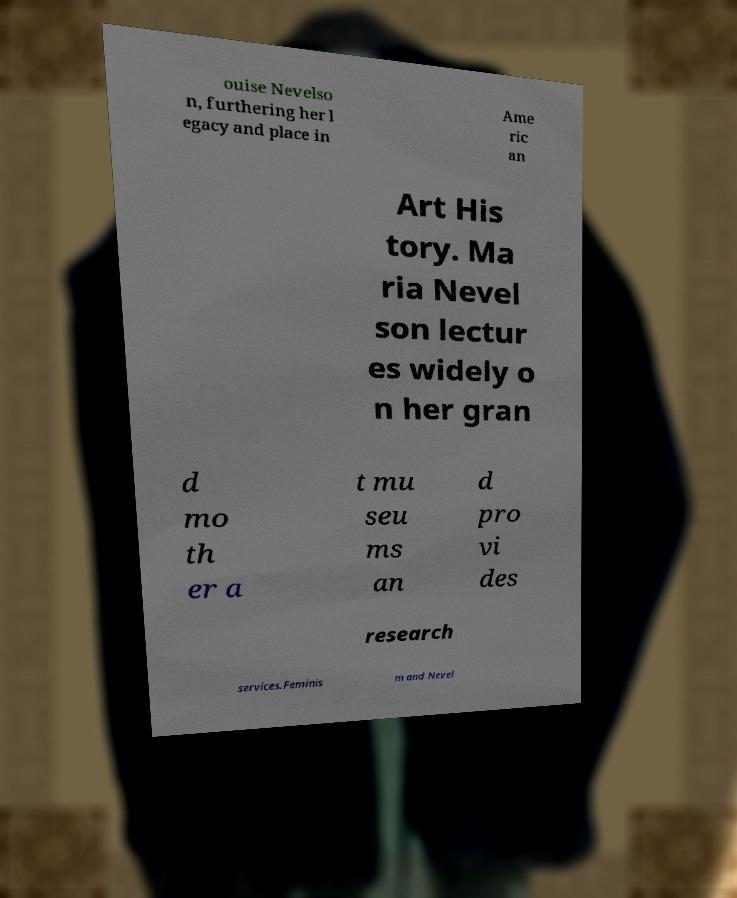Please identify and transcribe the text found in this image. ouise Nevelso n, furthering her l egacy and place in Ame ric an Art His tory. Ma ria Nevel son lectur es widely o n her gran d mo th er a t mu seu ms an d pro vi des research services.Feminis m and Nevel 